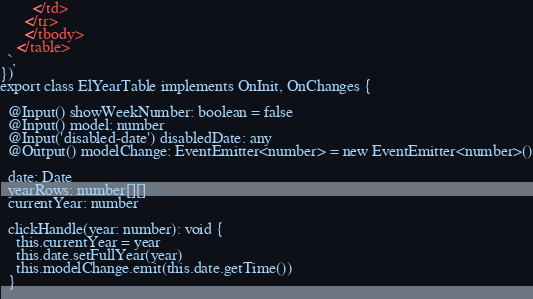<code> <loc_0><loc_0><loc_500><loc_500><_TypeScript_>        </td>
      </tr>
      </tbody>
    </table>
  `,
})
export class ElYearTable implements OnInit, OnChanges {
  
  @Input() showWeekNumber: boolean = false
  @Input() model: number
  @Input('disabled-date') disabledDate: any
  @Output() modelChange: EventEmitter<number> = new EventEmitter<number>()
  
  date: Date
  yearRows: number[][]
  currentYear: number
  
  clickHandle(year: number): void {
    this.currentYear = year
    this.date.setFullYear(year)
    this.modelChange.emit(this.date.getTime())
  }
  </code> 